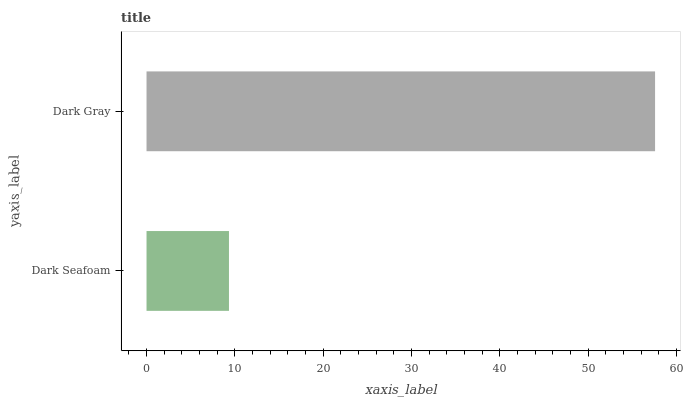Is Dark Seafoam the minimum?
Answer yes or no. Yes. Is Dark Gray the maximum?
Answer yes or no. Yes. Is Dark Gray the minimum?
Answer yes or no. No. Is Dark Gray greater than Dark Seafoam?
Answer yes or no. Yes. Is Dark Seafoam less than Dark Gray?
Answer yes or no. Yes. Is Dark Seafoam greater than Dark Gray?
Answer yes or no. No. Is Dark Gray less than Dark Seafoam?
Answer yes or no. No. Is Dark Gray the high median?
Answer yes or no. Yes. Is Dark Seafoam the low median?
Answer yes or no. Yes. Is Dark Seafoam the high median?
Answer yes or no. No. Is Dark Gray the low median?
Answer yes or no. No. 